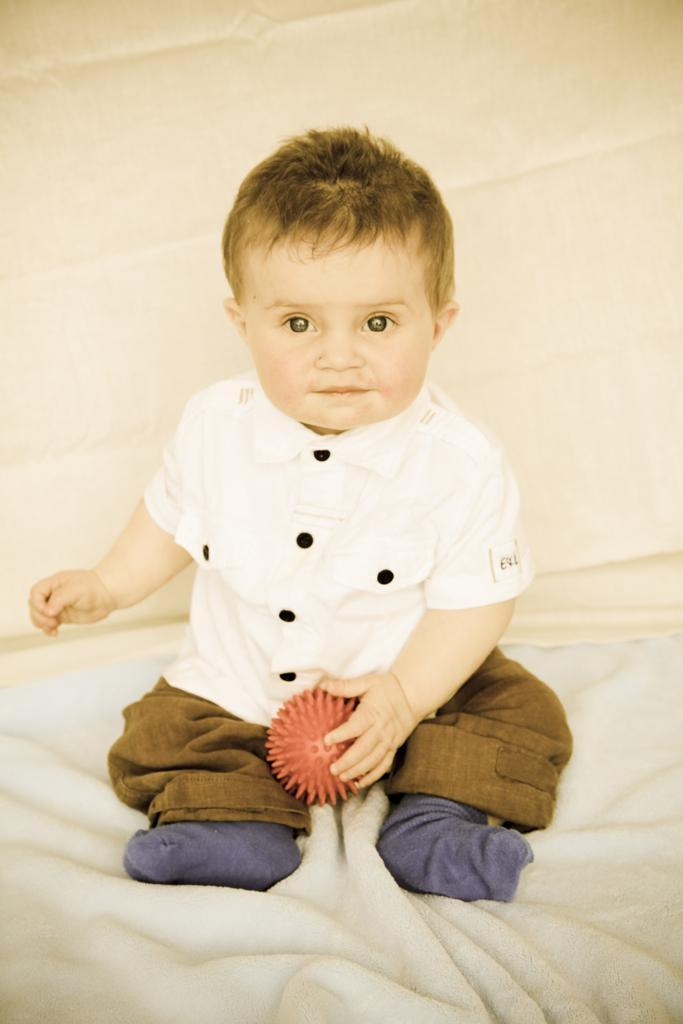Who is the main subject in the image? There is a boy in the image. What is the boy wearing? The boy is wearing a white shirt. What is the boy holding in the image? The boy is holding an object. What is the boy sitting on? The boy is sitting on a cloth. What can be seen behind the boy? There is a wall visible behind the boy. What type of animal is playing with the key in the snow in the image? There is no animal, key, or snow present in the image. 